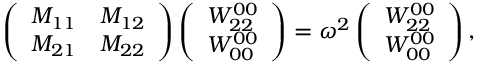Convert formula to latex. <formula><loc_0><loc_0><loc_500><loc_500>\left ( \begin{array} { c c } { { M _ { 1 1 } } } & { { M _ { 1 2 } } } \\ { { M _ { 2 1 } } } & { { M _ { 2 2 } } } \end{array} \right ) \left ( \begin{array} { c } { { W _ { 2 2 } ^ { 0 0 } } } \\ { { W _ { 0 0 } ^ { 0 0 } } } \end{array} \right ) = \omega ^ { 2 } \left ( \begin{array} { c } { { W _ { 2 2 } ^ { 0 0 } } } \\ { { W _ { 0 0 } ^ { 0 0 } } } \end{array} \right ) ,</formula> 